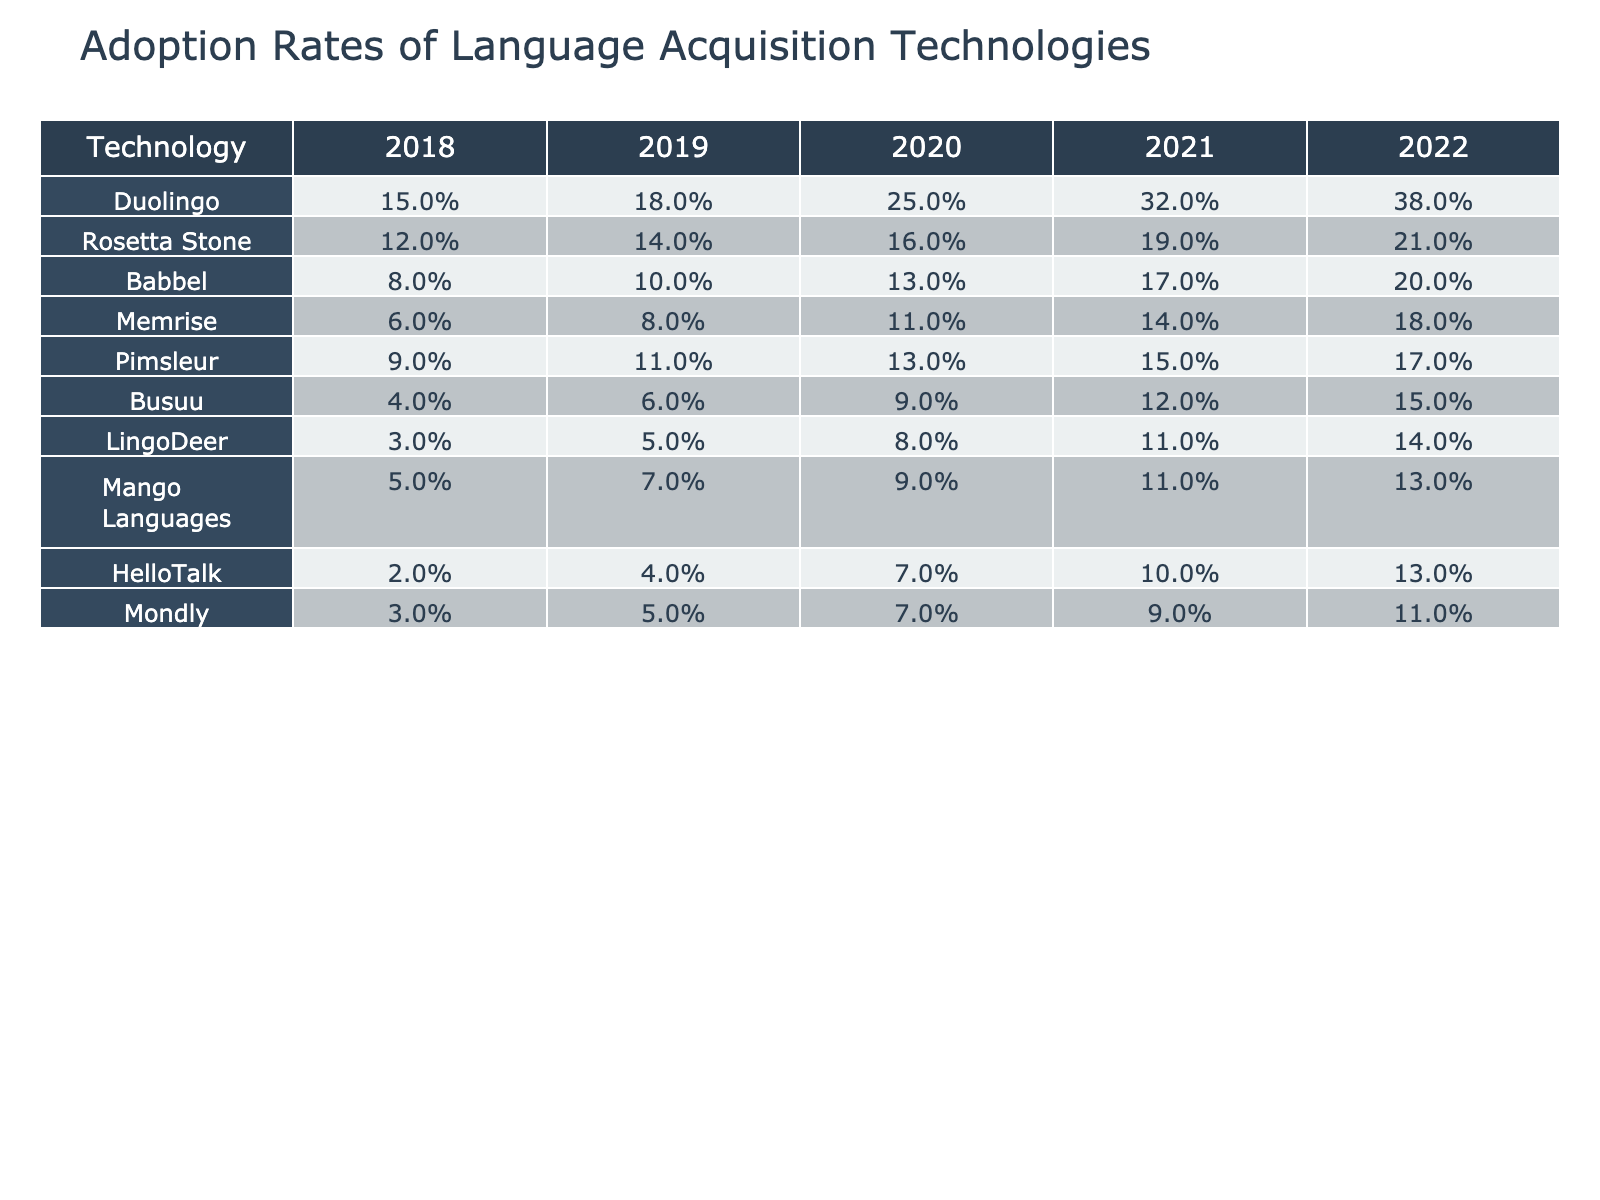What was the adoption rate of Duolingo in 2021? In the table for the year 2021, the adoption rate for Duolingo is listed as 32%.
Answer: 32% Which technology had the highest adoption rate in 2022? The table shows that in 2022, Duolingo had the highest adoption rate at 38%, compared to other technologies.
Answer: Duolingo What was the percentage increase in adoption rate for Babbel from 2018 to 2022? Babbel's adoption rates in 2018 and 2022 were 8% and 20%, respectively. The percentage increase is calculated as (20% - 8%) / 8% * 100% = 150%.
Answer: 150% Which technology had an adoption rate of 4% in 2019? The table indicates that Busuu had an adoption rate of 4% in 2019.
Answer: Busuu What is the average adoption rate of all technologies in 2020? To find the average for 2020, sum the rates: (25% + 16% + 13% + 11% + 13% + 9% + 8% + 9% + 7% + 7%) = 118%, and divide by the number of technologies (10): 118% / 10 = 11.8%.
Answer: 11.8% In which year did HelloTalk first reach a double-digit adoption rate? Looking at the table, HelloTalk reached a double-digit adoption rate in 2021, with a rate of 10%.
Answer: 2021 What was the difference in adoption rates between Pimsleur and Memrise in 2022? In 2022, Pimsleur had an adoption rate of 17% and Memrise had an adoption rate of 18%. The difference is 18% - 17% = 1%.
Answer: 1% True or False: The adoption rate of Mango Languages in 2020 was greater than 10%. According to the table, Mango Languages had an adoption rate of 9% in 2020, which is not greater than 10%.
Answer: False What is the cumulative adoption rate of the lowest three technologies listed in 2022? The lowest three technologies in 2022 are Busuu (15%), LingoDeer (14%), and HelloTalk (13%). Their cumulative adoption rate is 15% + 14% + 13% = 42%.
Answer: 42% How much did the adoption rate for Rosetta Stone increase from 2019 to 2021? Rosetta Stone's adoption rate increased from 14% in 2019 to 19% in 2021. The increase is 19% - 14% = 5%.
Answer: 5% 